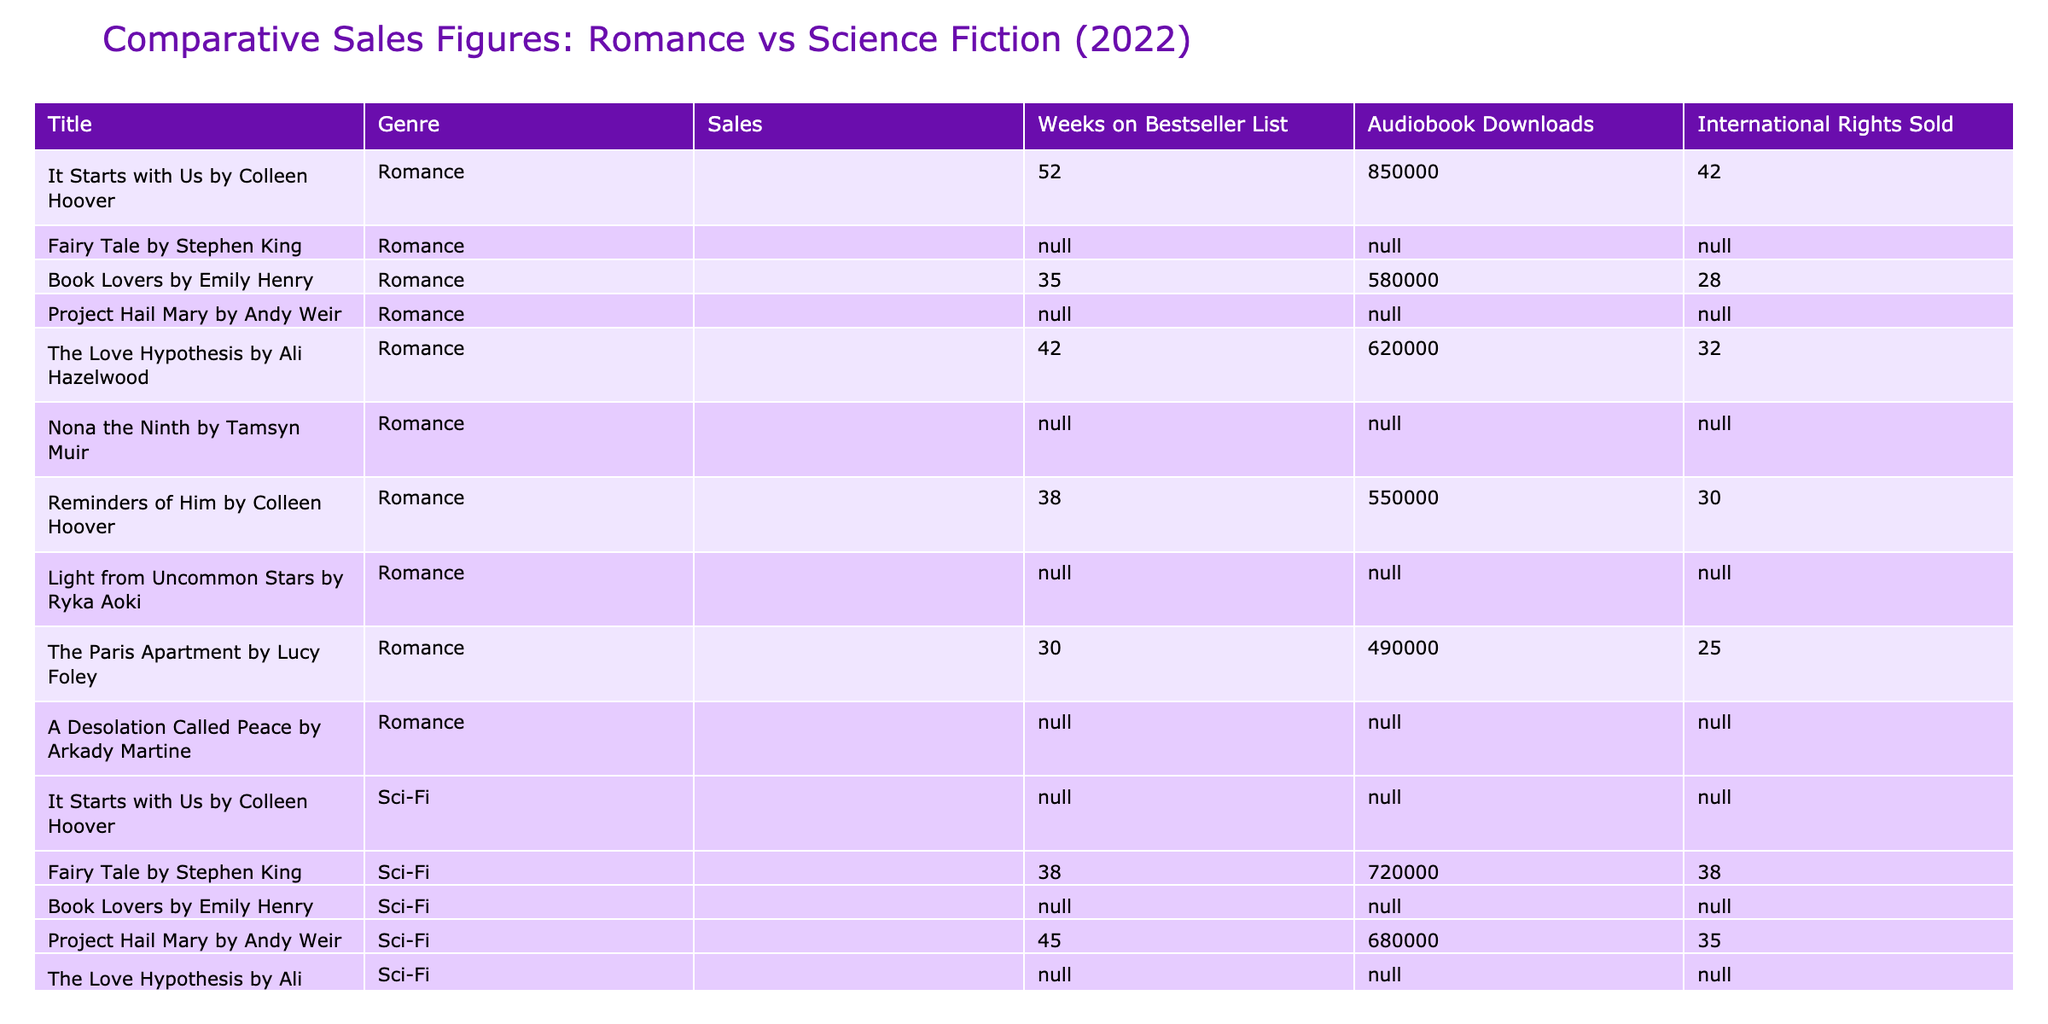What is the total sales figure for romance novels? The sales figures for each romance novel are listed: 2,100,000 + 950,000 + 880,000 + 820,000 + 750,000 = 5,500,000. By adding these amounts together, the total sales for romance novels in 2022 is 5,500,000.
Answer: 5,500,000 Which romance novel had the highest number of audiobook downloads? The audiobook downloads for romance novels are: 850,000, 580,000, 620,000, 550,000, and 490,000. Among these, 850,000 is the highest, belonging to "It Starts with Us."
Answer: It Starts with Us by Colleen Hoover Did any science fiction novels exceed 1 million sales? The sales figures for science fiction novels are 1,250,000 and 920,000. Since 1,250,000 is greater than 1 million, the statement is true.
Answer: Yes What is the difference in audiobook downloads between the best-selling romance and sci-fi novel? "It Starts with Us" sold 850,000 audiobooks in romance, while the best-selling sci-fi novel, "Fairy Tale," had no audiobook downloads listed (N/A). Because we cannot quantify N/A, we focus on the romance novel's total, which indicates it is higher.
Answer: 850,000 What average number of weeks did the top three romance novels spend on the bestseller list? The top three romance novels spent 52, 35, and 42 weeks on the list. Summing these gives 52 + 35 + 42 = 129 weeks; dividing by 3 gives us an average of 43.
Answer: 43 Which genre had more international rights sold overall? The total international rights sold for romance novels are 42 + 28 + 32 + 30 + 25 = 157, while sci-fi novels sold 38 + 35 + 25 + 22 = 120. Since 157 is greater than 120, romance outperformed.
Answer: Romance Which sci-fi novel had the most weeks on the bestseller list? The sci-fi novels' weeks on the bestseller list are 38, 45, 28, 22, and 20. The highest is 45 weeks for "Project Hail Mary."
Answer: Project Hail Mary How does the average sales figure for sci-fi compare to that of romance novels? The total sales for sci-fi is 1,250,000 + 920,000 + 780,000 + 710,000 + 680,000 = 4,340,000 for 5 books. The average is 4,340,000 / 5 = 868,000. For romance, the average is 5,500,000 / 5 = 1,100,000. Since 1,100,000 is greater than 868,000, romance averages higher.
Answer: Romance averages higher Which title sold the least units across both genres? The sales figures in sci-fi are 680,000 (A Desolation Called Peace) and for romance, the least sold was 750,000 (The Paris Apartment). Comparing these, A Desolation Called Peace sold less.
Answer: A Desolation Called Peace Are there any romance novels that were on the bestseller list for more than 40 weeks? The weeks on the bestseller list for romance novels are: 52, 35, 42, 38, and 30. All except "Book Lovers" and "The Paris Apartment" exceeded 40 weeks, so yes, there are two.
Answer: Yes What percentage of total romance sales came from "It Starts with Us"? "It Starts with Us" sold 2,100,000 copies, and the total romance sales figure is 5,500,000. The percentage is (2,100,000 / 5,500,000) * 100, which equals 38.18%.
Answer: 38.18% 